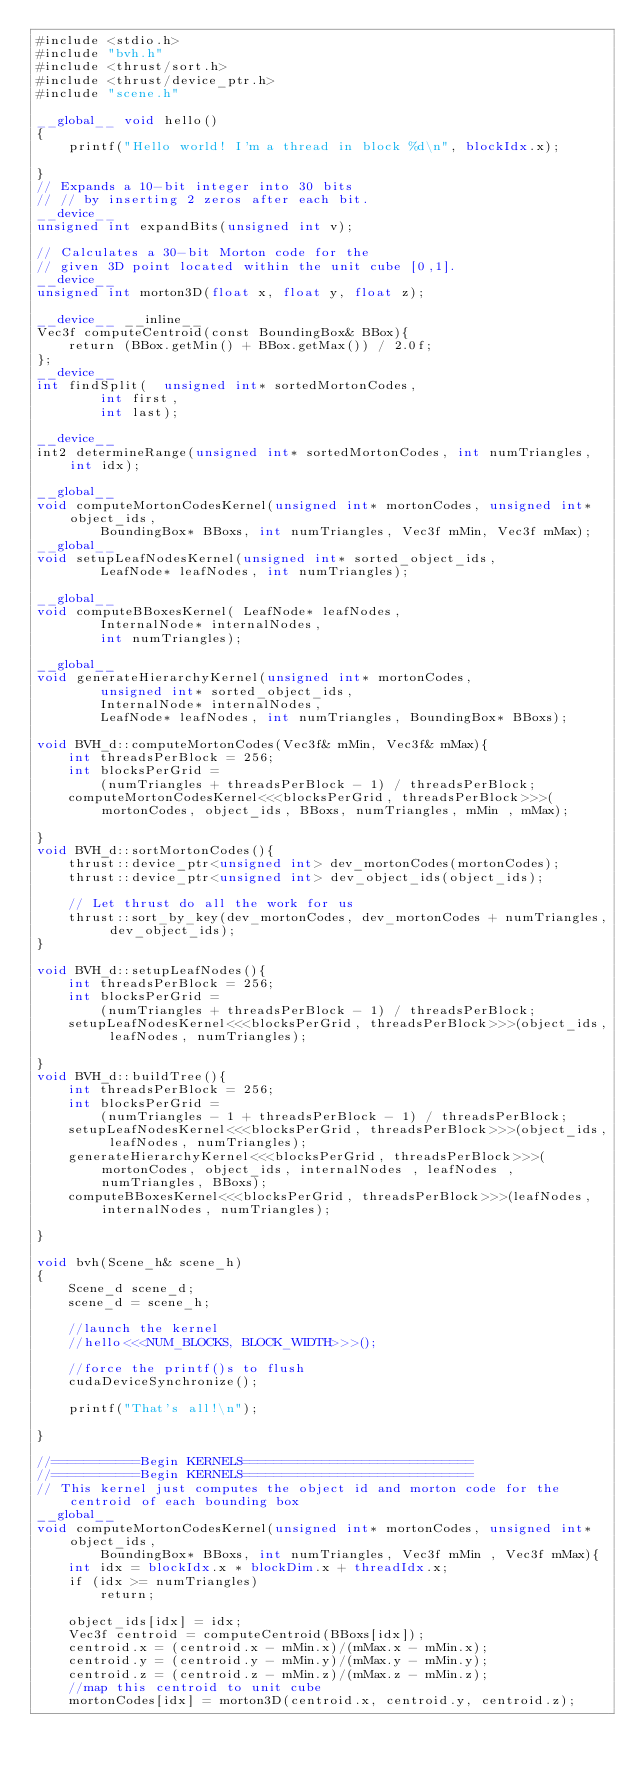<code> <loc_0><loc_0><loc_500><loc_500><_Cuda_>#include <stdio.h>
#include "bvh.h"
#include <thrust/sort.h>
#include <thrust/device_ptr.h>
#include "scene.h"

__global__ void hello()
{
    printf("Hello world! I'm a thread in block %d\n", blockIdx.x);

}
// Expands a 10-bit integer into 30 bits
// // by inserting 2 zeros after each bit.
__device__
unsigned int expandBits(unsigned int v);

// Calculates a 30-bit Morton code for the
// given 3D point located within the unit cube [0,1].
__device__
unsigned int morton3D(float x, float y, float z);

__device__ __inline__
Vec3f computeCentroid(const BoundingBox& BBox){
    return (BBox.getMin() + BBox.getMax()) / 2.0f;
};
__device__
int findSplit(  unsigned int* sortedMortonCodes,
        int first,
        int last);

__device__
int2 determineRange(unsigned int* sortedMortonCodes, int numTriangles, int idx);

__global__ 
void computeMortonCodesKernel(unsigned int* mortonCodes, unsigned int* object_ids, 
        BoundingBox* BBoxs, int numTriangles, Vec3f mMin, Vec3f mMax);
__global__ 
void setupLeafNodesKernel(unsigned int* sorted_object_ids, 
        LeafNode* leafNodes, int numTriangles);

__global__ 
void computeBBoxesKernel( LeafNode* leafNodes,
        InternalNode* internalNodes,
        int numTriangles);

__global__ 
void generateHierarchyKernel(unsigned int* mortonCodes,
        unsigned int* sorted_object_ids, 
        InternalNode* internalNodes,
        LeafNode* leafNodes, int numTriangles, BoundingBox* BBoxs);

void BVH_d::computeMortonCodes(Vec3f& mMin, Vec3f& mMax){
    int threadsPerBlock = 256;
    int blocksPerGrid =
        (numTriangles + threadsPerBlock - 1) / threadsPerBlock;
    computeMortonCodesKernel<<<blocksPerGrid, threadsPerBlock>>>(mortonCodes, object_ids, BBoxs, numTriangles, mMin , mMax);

}
void BVH_d::sortMortonCodes(){
    thrust::device_ptr<unsigned int> dev_mortonCodes(mortonCodes);
    thrust::device_ptr<unsigned int> dev_object_ids(object_ids);

    // Let thrust do all the work for us
    thrust::sort_by_key(dev_mortonCodes, dev_mortonCodes + numTriangles, dev_object_ids);
}

void BVH_d::setupLeafNodes(){
    int threadsPerBlock = 256;
    int blocksPerGrid =
        (numTriangles + threadsPerBlock - 1) / threadsPerBlock;
    setupLeafNodesKernel<<<blocksPerGrid, threadsPerBlock>>>(object_ids, leafNodes, numTriangles);

}
void BVH_d::buildTree(){
    int threadsPerBlock = 256;
    int blocksPerGrid =
        (numTriangles - 1 + threadsPerBlock - 1) / threadsPerBlock;
    setupLeafNodesKernel<<<blocksPerGrid, threadsPerBlock>>>(object_ids, leafNodes, numTriangles);
    generateHierarchyKernel<<<blocksPerGrid, threadsPerBlock>>>(mortonCodes, object_ids, internalNodes , leafNodes , numTriangles, BBoxs);
    computeBBoxesKernel<<<blocksPerGrid, threadsPerBlock>>>(leafNodes, internalNodes, numTriangles);

}

void bvh(Scene_h& scene_h)
{
    Scene_d scene_d;
    scene_d = scene_h;
    
    //launch the kernel
    //hello<<<NUM_BLOCKS, BLOCK_WIDTH>>>();

    //force the printf()s to flush
    cudaDeviceSynchronize();

    printf("That's all!\n");

}

//===========Begin KERNELS=============================
//===========Begin KERNELS=============================
// This kernel just computes the object id and morton code for the centroid of each bounding box
__global__ 
void computeMortonCodesKernel(unsigned int* mortonCodes, unsigned int* object_ids, 
        BoundingBox* BBoxs, int numTriangles, Vec3f mMin , Vec3f mMax){
    int idx = blockIdx.x * blockDim.x + threadIdx.x;
    if (idx >= numTriangles)
        return;

    object_ids[idx] = idx;
    Vec3f centroid = computeCentroid(BBoxs[idx]);
    centroid.x = (centroid.x - mMin.x)/(mMax.x - mMin.x);
    centroid.y = (centroid.y - mMin.y)/(mMax.y - mMin.y);
    centroid.z = (centroid.z - mMin.z)/(mMax.z - mMin.z);
    //map this centroid to unit cube
    mortonCodes[idx] = morton3D(centroid.x, centroid.y, centroid.z);</code> 